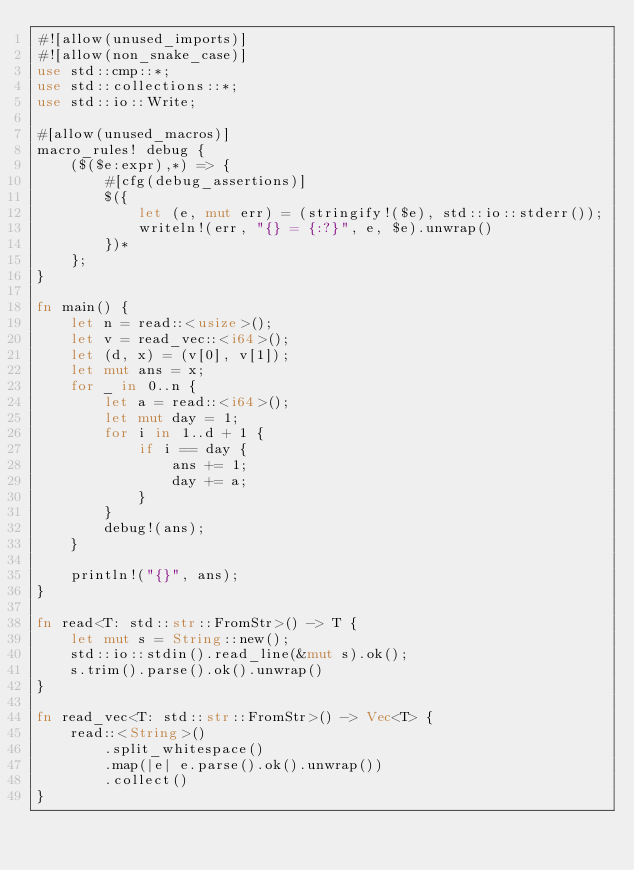Convert code to text. <code><loc_0><loc_0><loc_500><loc_500><_Rust_>#![allow(unused_imports)]
#![allow(non_snake_case)]
use std::cmp::*;
use std::collections::*;
use std::io::Write;

#[allow(unused_macros)]
macro_rules! debug {
    ($($e:expr),*) => {
        #[cfg(debug_assertions)]
        $({
            let (e, mut err) = (stringify!($e), std::io::stderr());
            writeln!(err, "{} = {:?}", e, $e).unwrap()
        })*
    };
}

fn main() {
    let n = read::<usize>();
    let v = read_vec::<i64>();
    let (d, x) = (v[0], v[1]);
    let mut ans = x;
    for _ in 0..n {
        let a = read::<i64>();
        let mut day = 1;
        for i in 1..d + 1 {
            if i == day {
                ans += 1;
                day += a;
            }
        }
        debug!(ans);
    }

    println!("{}", ans);
}

fn read<T: std::str::FromStr>() -> T {
    let mut s = String::new();
    std::io::stdin().read_line(&mut s).ok();
    s.trim().parse().ok().unwrap()
}

fn read_vec<T: std::str::FromStr>() -> Vec<T> {
    read::<String>()
        .split_whitespace()
        .map(|e| e.parse().ok().unwrap())
        .collect()
}
</code> 